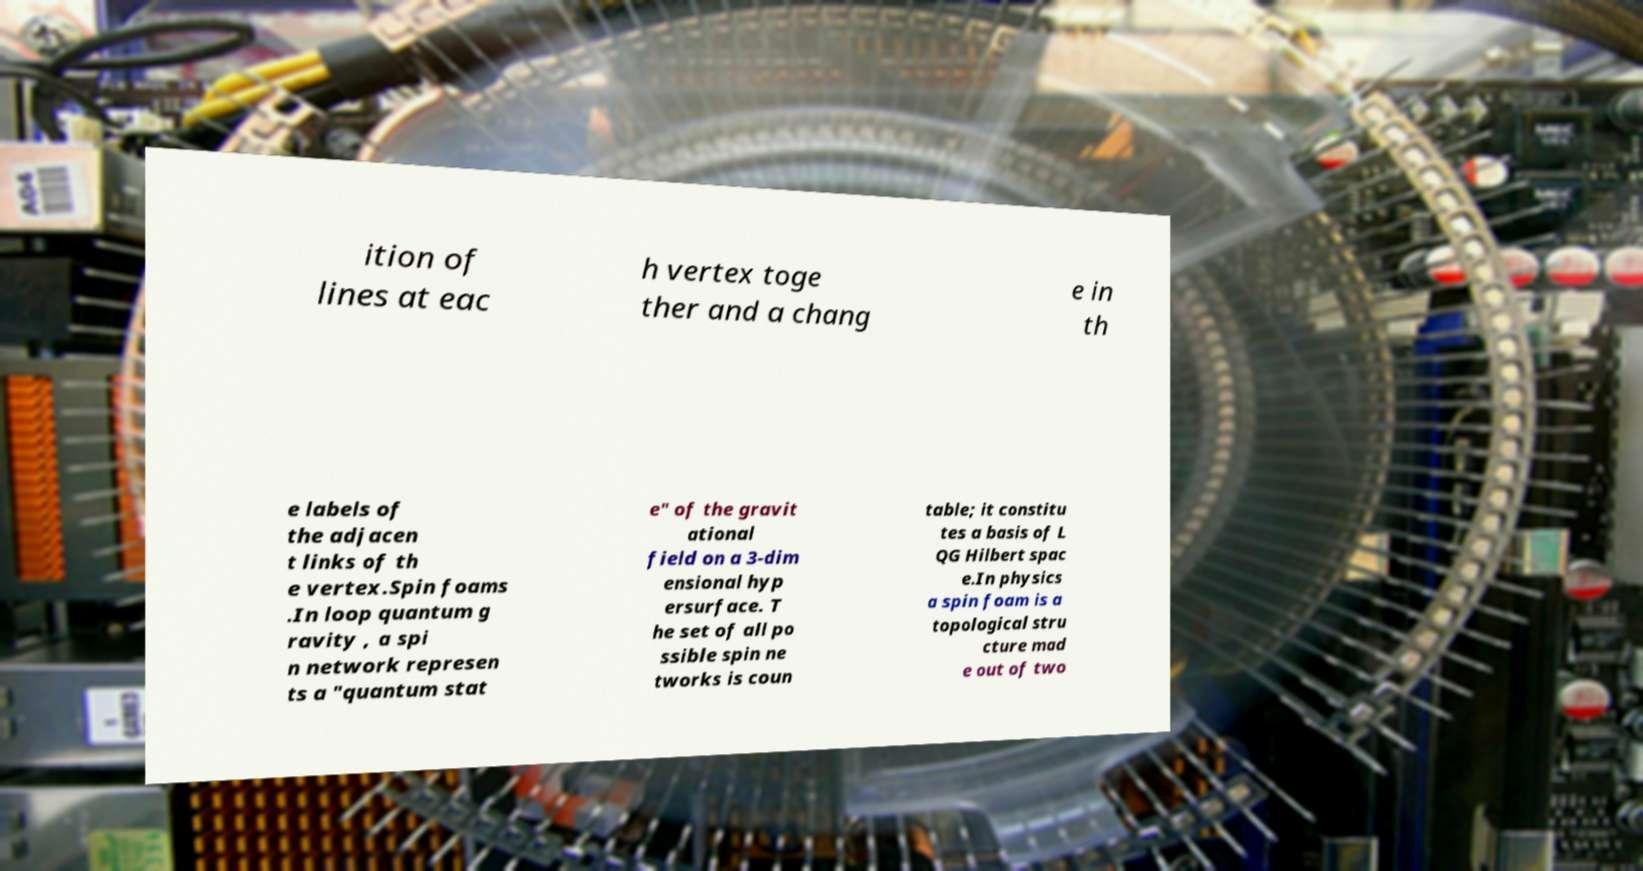I need the written content from this picture converted into text. Can you do that? ition of lines at eac h vertex toge ther and a chang e in th e labels of the adjacen t links of th e vertex.Spin foams .In loop quantum g ravity , a spi n network represen ts a "quantum stat e" of the gravit ational field on a 3-dim ensional hyp ersurface. T he set of all po ssible spin ne tworks is coun table; it constitu tes a basis of L QG Hilbert spac e.In physics a spin foam is a topological stru cture mad e out of two 